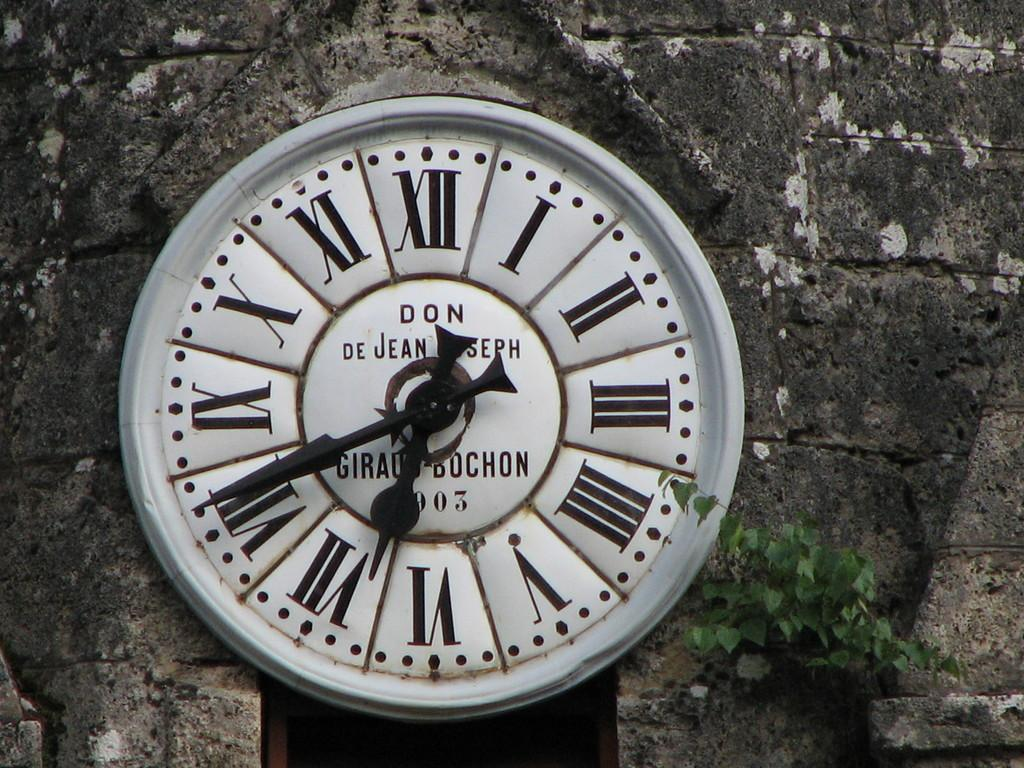<image>
Provide a brief description of the given image. A large analouge clock that is mostly white at 6:40. 